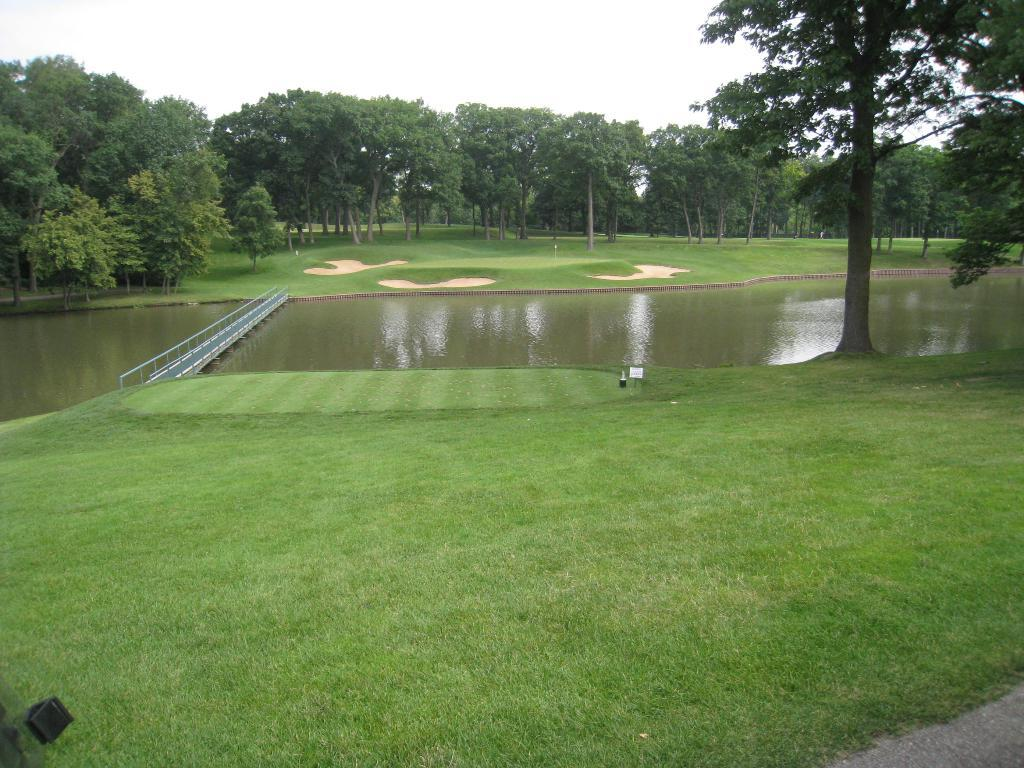What type of terrain is visible in the image? There is grassy land in the image. What structure can be seen crossing the grassy land? There is a bridge in the image. What body of water is present in the image? There is a lake in the image. What type of vegetation is visible in the background of the image? Trees are present in the background of the image. What is the condition of the sky in the image? The sky is covered with clouds. Where is the volcano located in the image? There is no volcano present in the image. What type of test can be seen being conducted on the slope in the image? There is no slope or test present in the image. 